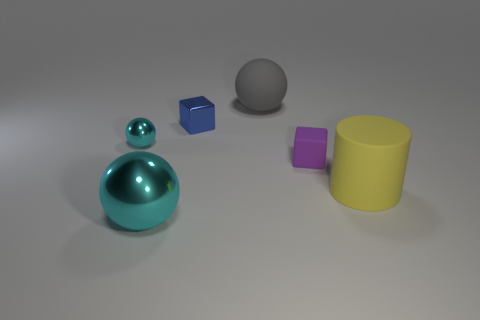Can you describe the lighting and shadows in the image? The lighting in the image is diffused, casting soft shadows on the right side of the objects, indicating the light source is coming from the left. There are no harsh highlights, and shadows are subtle with soft edges, suggesting an ambient light setup that mimics a cloudy day or indoor lighting with multiple sources. 